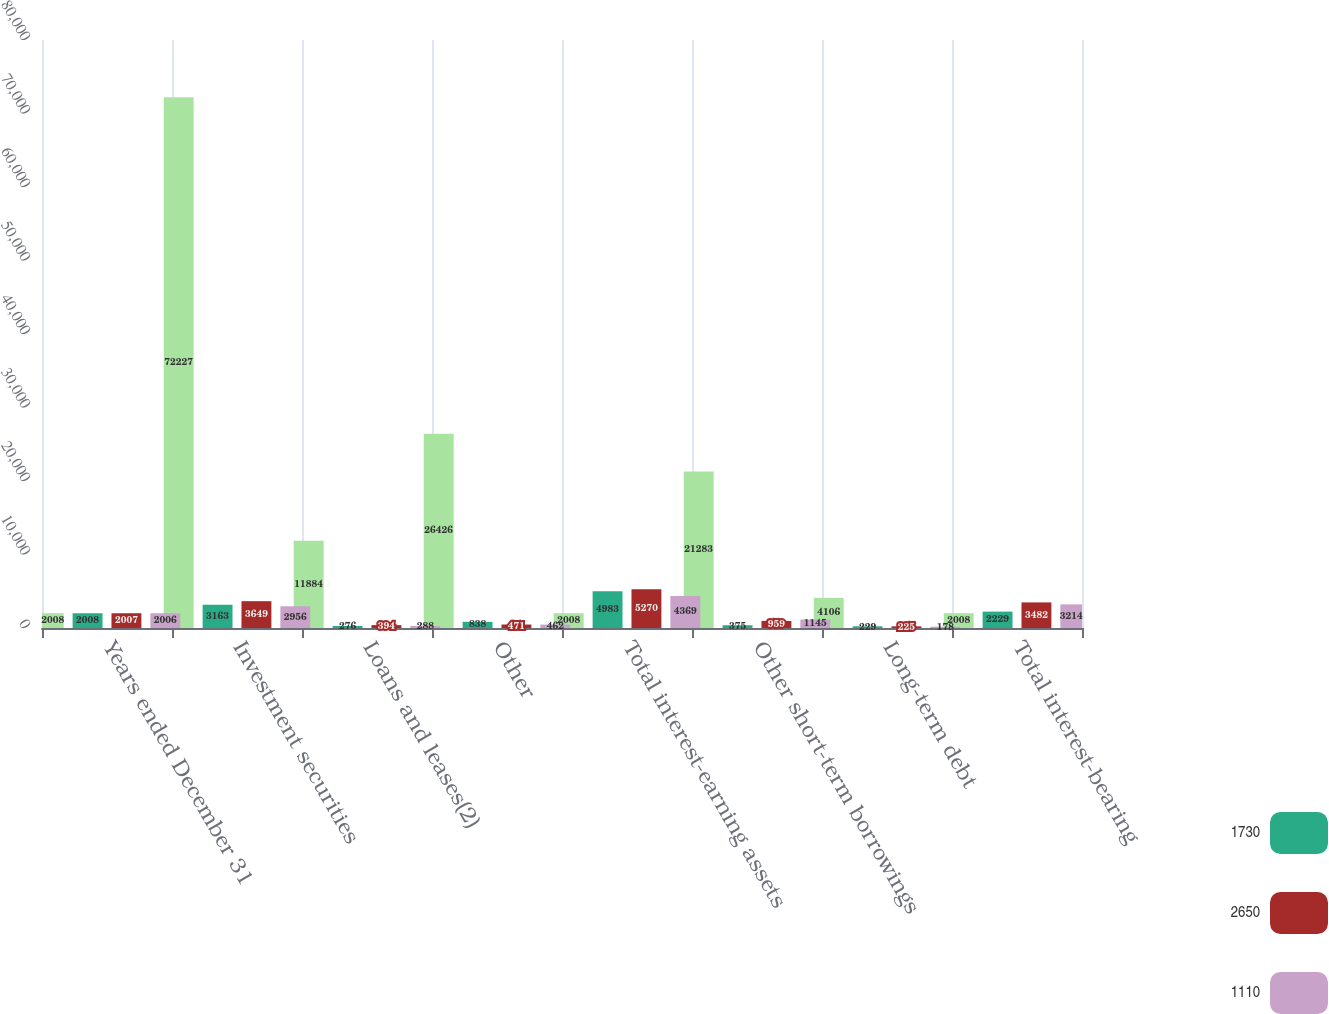<chart> <loc_0><loc_0><loc_500><loc_500><stacked_bar_chart><ecel><fcel>Years ended December 31<fcel>Investment securities<fcel>Loans and leases(2)<fcel>Other<fcel>Total interest-earning assets<fcel>Other short-term borrowings<fcel>Long-term debt<fcel>Total interest-bearing<nl><fcel>nan<fcel>2008<fcel>72227<fcel>11884<fcel>26426<fcel>2008<fcel>21283<fcel>4106<fcel>2008<nl><fcel>1730<fcel>2008<fcel>3163<fcel>276<fcel>838<fcel>4983<fcel>375<fcel>229<fcel>2229<nl><fcel>2650<fcel>2007<fcel>3649<fcel>394<fcel>471<fcel>5270<fcel>959<fcel>225<fcel>3482<nl><fcel>1110<fcel>2006<fcel>2956<fcel>288<fcel>462<fcel>4369<fcel>1145<fcel>178<fcel>3214<nl></chart> 